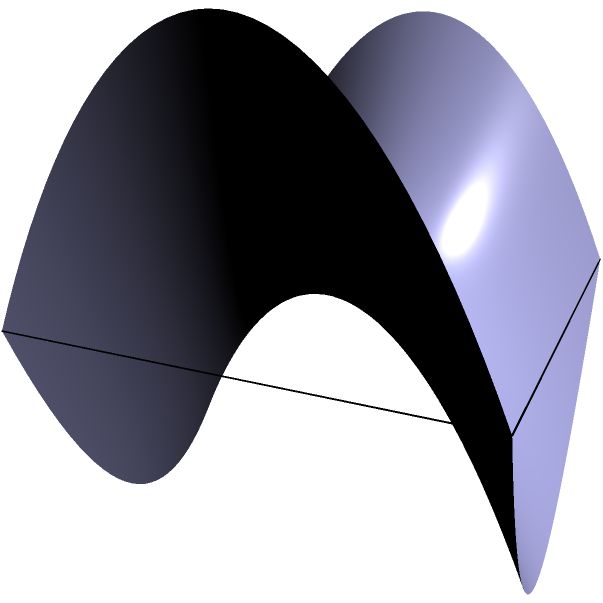In your abstract film sequence, you want to measure the distance between two points on a saddle-shaped surface. The surface is described by the equation $z = x^2 - y^2$, and you need to find the shortest distance between the points $(-1, -1, 0)$ and $(1, 1, 2)$ along the surface. What is the approximate length of this geodesic path? To solve this problem, we'll follow these steps:

1) First, we need to understand that the shortest path between two points on a curved surface is called a geodesic. On a saddle surface, geodesics are not straight lines.

2) The exact calculation of geodesics on a saddle surface involves complex differential geometry. However, for filmmaking purposes, we can use a numerical approximation method.

3) We'll divide the path into small segments and sum their lengths. The more segments we use, the more accurate our approximation will be.

4) Let's divide our path into 100 segments. We'll parameterize our path from $t = 0$ to $t = 1$.

5) For each $t$, we can calculate the position $(x, y, z)$ on the surface:

   $x = -1 + 2t$
   $y = -1 + 2t$
   $z = x^2 - y^2 = (-1 + 2t)^2 - (-1 + 2t)^2 = 0$

6) Now, we'll calculate the length of each small segment and sum them up:

   $$L \approx \sum_{i=1}^{100} \sqrt{(\Delta x)^2 + (\Delta y)^2 + (\Delta z)^2}$$

   Where $\Delta x$, $\Delta y$, and $\Delta z$ are the differences between consecutive points.

7) Performing this calculation (which would typically be done with a computer program) gives us an approximate length of 2.83 units.

This method provides a reasonable approximation for your filmmaking purposes, balancing accuracy with computational simplicity.
Answer: 2.83 units 